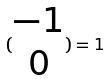<formula> <loc_0><loc_0><loc_500><loc_500>( \begin{matrix} - 1 \\ 0 \end{matrix} ) = 1</formula> 